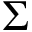Convert formula to latex. <formula><loc_0><loc_0><loc_500><loc_500>\Sigma</formula> 